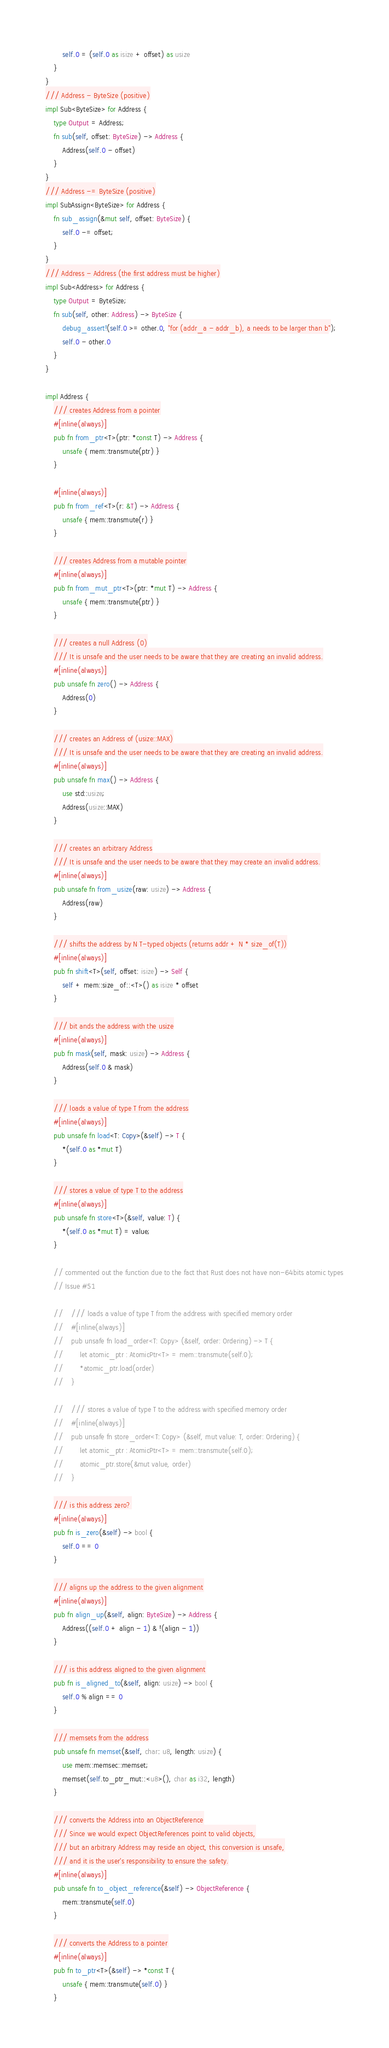<code> <loc_0><loc_0><loc_500><loc_500><_Rust_>        self.0 = (self.0 as isize + offset) as usize
    }
}
/// Address - ByteSize (positive)
impl Sub<ByteSize> for Address {
    type Output = Address;
    fn sub(self, offset: ByteSize) -> Address {
        Address(self.0 - offset)
    }
}
/// Address -= ByteSize (positive)
impl SubAssign<ByteSize> for Address {
    fn sub_assign(&mut self, offset: ByteSize) {
        self.0 -= offset;
    }
}
/// Address - Address (the first address must be higher)
impl Sub<Address> for Address {
    type Output = ByteSize;
    fn sub(self, other: Address) -> ByteSize {
        debug_assert!(self.0 >= other.0, "for (addr_a - addr_b), a needs to be larger than b");
        self.0 - other.0
    }
}

impl Address {
    /// creates Address from a pointer
    #[inline(always)]
    pub fn from_ptr<T>(ptr: *const T) -> Address {
        unsafe { mem::transmute(ptr) }
    }

    #[inline(always)]
    pub fn from_ref<T>(r: &T) -> Address {
        unsafe { mem::transmute(r) }
    }

    /// creates Address from a mutable pointer
    #[inline(always)]
    pub fn from_mut_ptr<T>(ptr: *mut T) -> Address {
        unsafe { mem::transmute(ptr) }
    }

    /// creates a null Address (0)
    /// It is unsafe and the user needs to be aware that they are creating an invalid address.
    #[inline(always)]
    pub unsafe fn zero() -> Address {
        Address(0)
    }

    /// creates an Address of (usize::MAX)
    /// It is unsafe and the user needs to be aware that they are creating an invalid address.
    #[inline(always)]
    pub unsafe fn max() -> Address {
        use std::usize;
        Address(usize::MAX)
    }

    /// creates an arbitrary Address
    /// It is unsafe and the user needs to be aware that they may create an invalid address.
    #[inline(always)]
    pub unsafe fn from_usize(raw: usize) -> Address {
        Address(raw)
    }

    /// shifts the address by N T-typed objects (returns addr + N * size_of(T))
    #[inline(always)]
    pub fn shift<T>(self, offset: isize) -> Self {
        self + mem::size_of::<T>() as isize * offset
    }

    /// bit ands the address with the usize
    #[inline(always)]
    pub fn mask(self, mask: usize) -> Address {
        Address(self.0 & mask)
    }

    /// loads a value of type T from the address
    #[inline(always)]
    pub unsafe fn load<T: Copy>(&self) -> T {
        *(self.0 as *mut T)
    }

    /// stores a value of type T to the address
    #[inline(always)]
    pub unsafe fn store<T>(&self, value: T) {
        *(self.0 as *mut T) = value;
    }

    // commented out the function due to the fact that Rust does not have non-64bits atomic types
    // Issue #51

    //    /// loads a value of type T from the address with specified memory order
    //    #[inline(always)]
    //    pub unsafe fn load_order<T: Copy> (&self, order: Ordering) -> T {
    //        let atomic_ptr : AtomicPtr<T> = mem::transmute(self.0);
    //        *atomic_ptr.load(order)
    //    }

    //    /// stores a value of type T to the address with specified memory order
    //    #[inline(always)]
    //    pub unsafe fn store_order<T: Copy> (&self, mut value: T, order: Ordering) {
    //        let atomic_ptr : AtomicPtr<T> = mem::transmute(self.0);
    //        atomic_ptr.store(&mut value, order)
    //    }

    /// is this address zero?
    #[inline(always)]
    pub fn is_zero(&self) -> bool {
        self.0 == 0
    }

    /// aligns up the address to the given alignment
    #[inline(always)]
    pub fn align_up(&self, align: ByteSize) -> Address {
        Address((self.0 + align - 1) & !(align - 1))
    }

    /// is this address aligned to the given alignment
    pub fn is_aligned_to(&self, align: usize) -> bool {
        self.0 % align == 0
    }

    /// memsets from the address
    pub unsafe fn memset(&self, char: u8, length: usize) {
        use mem::memsec::memset;
        memset(self.to_ptr_mut::<u8>(), char as i32, length)
    }

    /// converts the Address into an ObjectReference
    /// Since we would expect ObjectReferences point to valid objects,
    /// but an arbitrary Address may reside an object, this conversion is unsafe,
    /// and it is the user's responsibility to ensure the safety.
    #[inline(always)]
    pub unsafe fn to_object_reference(&self) -> ObjectReference {
        mem::transmute(self.0)
    }

    /// converts the Address to a pointer
    #[inline(always)]
    pub fn to_ptr<T>(&self) -> *const T {
        unsafe { mem::transmute(self.0) }
    }
</code> 